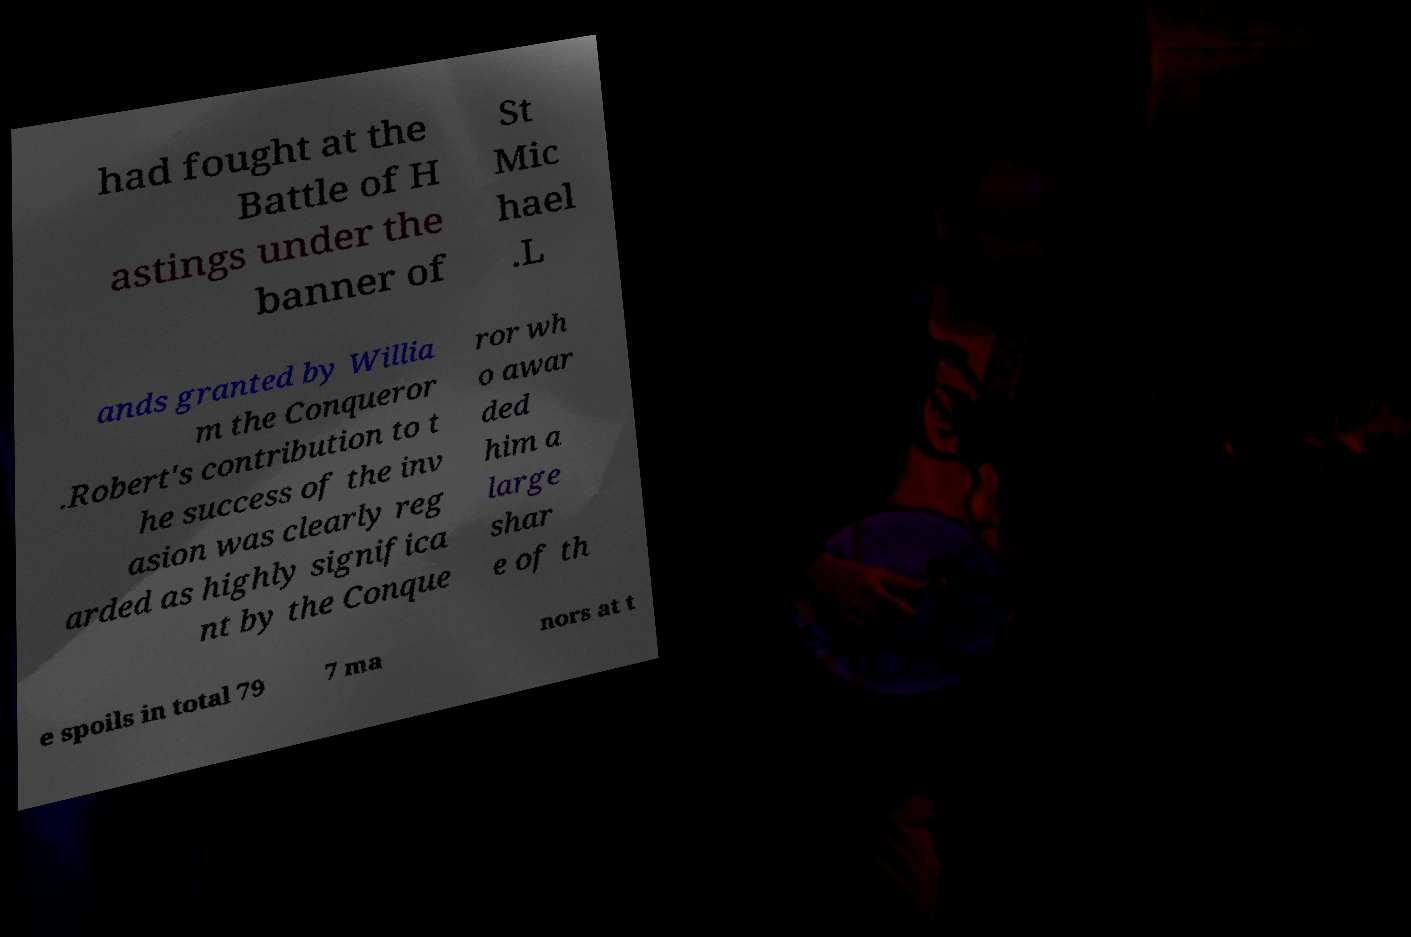Can you accurately transcribe the text from the provided image for me? had fought at the Battle of H astings under the banner of St Mic hael .L ands granted by Willia m the Conqueror .Robert's contribution to t he success of the inv asion was clearly reg arded as highly significa nt by the Conque ror wh o awar ded him a large shar e of th e spoils in total 79 7 ma nors at t 